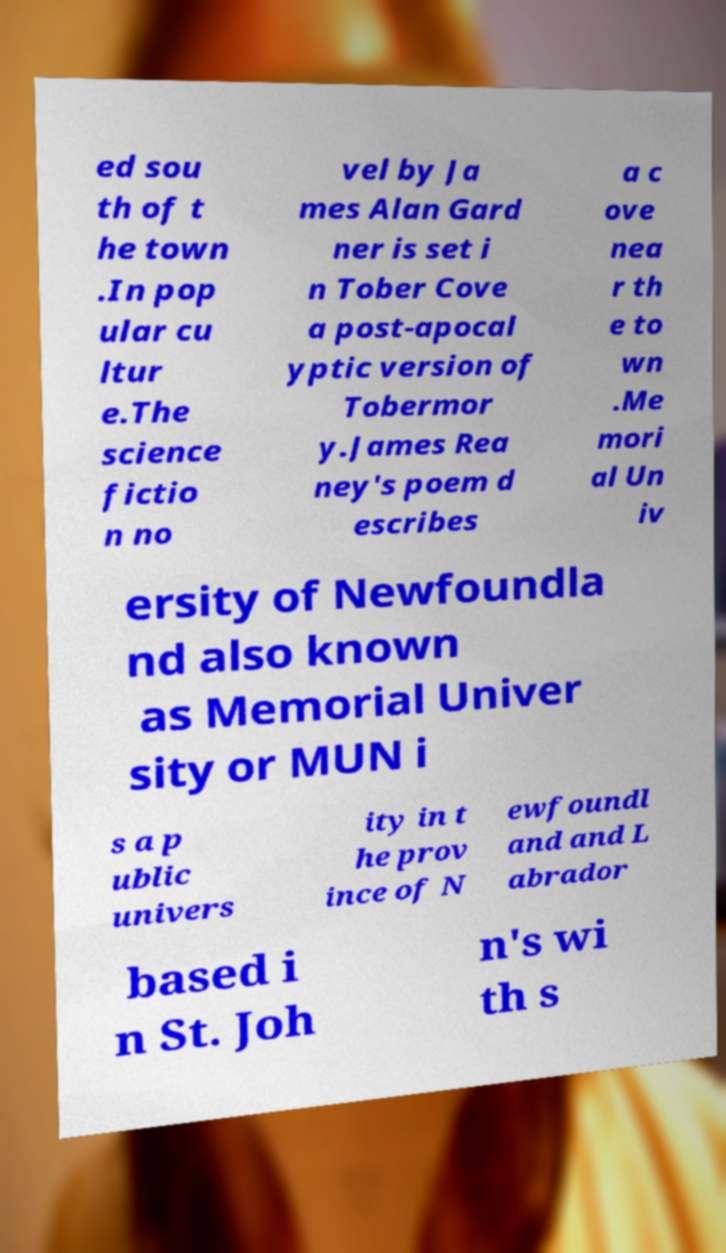Please read and relay the text visible in this image. What does it say? ed sou th of t he town .In pop ular cu ltur e.The science fictio n no vel by Ja mes Alan Gard ner is set i n Tober Cove a post-apocal yptic version of Tobermor y.James Rea ney's poem d escribes a c ove nea r th e to wn .Me mori al Un iv ersity of Newfoundla nd also known as Memorial Univer sity or MUN i s a p ublic univers ity in t he prov ince of N ewfoundl and and L abrador based i n St. Joh n's wi th s 